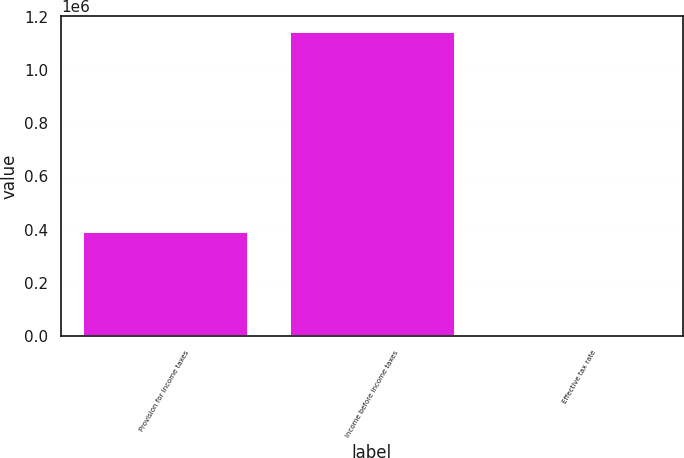<chart> <loc_0><loc_0><loc_500><loc_500><bar_chart><fcel>Provision for income taxes<fcel>Income before income taxes<fcel>Effective tax rate<nl><fcel>395203<fcel>1.1459e+06<fcel>34.5<nl></chart> 